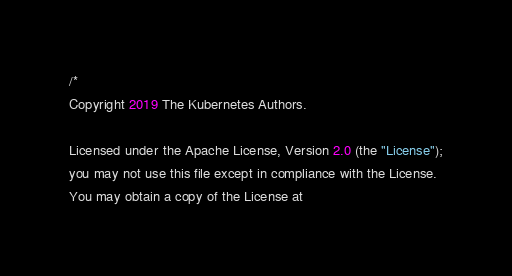<code> <loc_0><loc_0><loc_500><loc_500><_Go_>/*
Copyright 2019 The Kubernetes Authors.

Licensed under the Apache License, Version 2.0 (the "License");
you may not use this file except in compliance with the License.
You may obtain a copy of the License at
</code> 